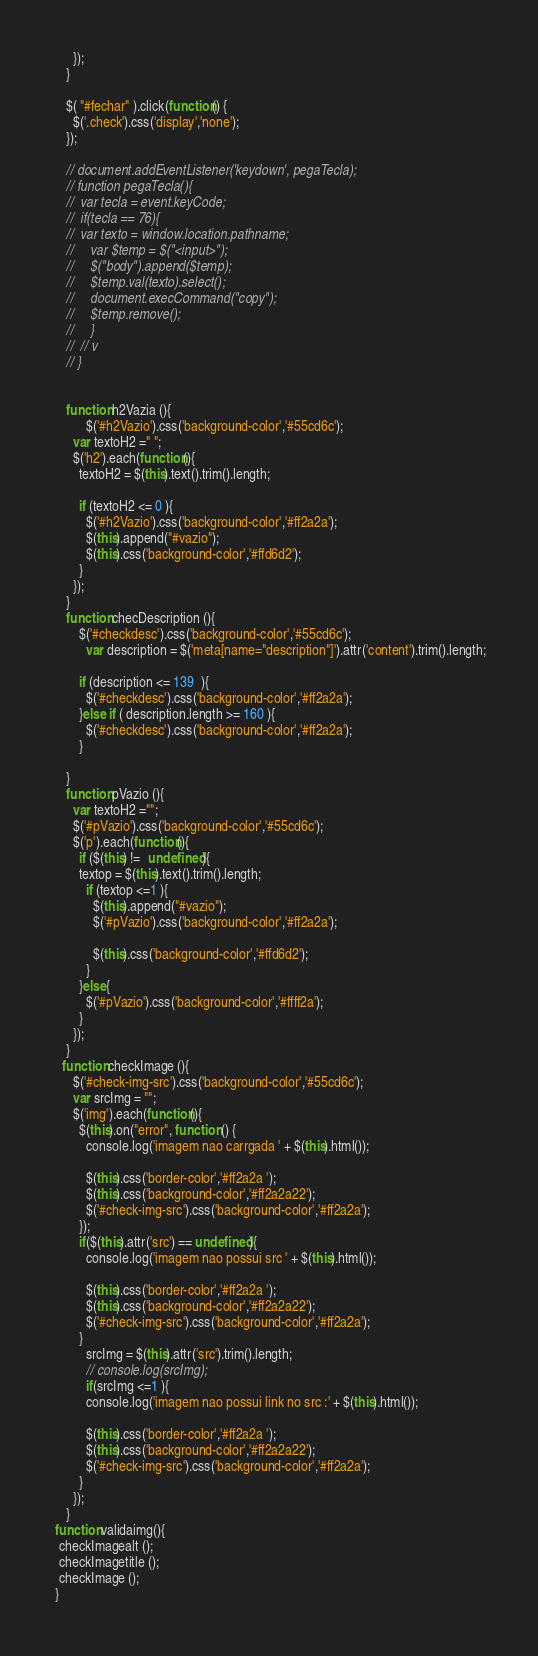Convert code to text. <code><loc_0><loc_0><loc_500><loc_500><_JavaScript_>      });
    }

    $( "#fechar" ).click(function() {
      $('.check').css('display','none');
    });

    // document.addEventListener('keydown', pegaTecla);
    // function pegaTecla(){
    //  var tecla = event.keyCode;
    //  if(tecla == 76){
    //  var texto = window.location.pathname;
    //     var $temp = $("<input>");
    //     $("body").append($temp);
    //     $temp.val(texto).select();
    //     document.execCommand("copy");
    //     $temp.remove();
    //     }
    //  // v
    // }


    function h2Vazia (){
          $('#h2Vazio').css('background-color','#55cd6c');
      var textoH2 =" ";
      $('h2').each(function(){
        textoH2 = $(this).text().trim().length;

        if (textoH2 <= 0 ){
          $('#h2Vazio').css('background-color','#ff2a2a');
          $(this).append("#vazio");
          $(this).css('background-color','#ffd6d2');
        }
      });
    }    
    function checDescription (){
        $('#checkdesc').css('background-color','#55cd6c');
          var description = $('meta[name="description"]').attr('content').trim().length;
          
        if (description <= 139  ){
          $('#checkdesc').css('background-color','#ff2a2a');
        }else if ( description.length >= 160 ){
          $('#checkdesc').css('background-color','#ff2a2a');
        }

    }
    function pVazio (){
      var textoH2 ="";
      $('#pVazio').css('background-color','#55cd6c');
      $('p').each(function(){
        if ($(this) !=  undefined){
        textop = $(this).text().trim().length;
          if (textop <=1 ){
            $(this).append("#vazio");
            $('#pVazio').css('background-color','#ff2a2a');
         
            $(this).css('background-color','#ffd6d2');
          }
        }else{
          $('#pVazio').css('background-color','#ffff2a');
        }
      });
    }
   function checkImage (){
      $('#check-img-src').css('background-color','#55cd6c');
      var srcImg = "";
      $('img').each(function(){
        $(this).on("error", function () {
          console.log('imagem nao carrgada ' + $(this).html());
          
          $(this).css('border-color','#ff2a2a ');
          $(this).css('background-color','#ff2a2a22');
          $('#check-img-src').css('background-color','#ff2a2a');
        });
        if($(this).attr('src') == undefined){
          console.log('imagem nao possui src ' + $(this).html());
          
          $(this).css('border-color','#ff2a2a ');
          $(this).css('background-color','#ff2a2a22');
          $('#check-img-src').css('background-color','#ff2a2a');
        }
          srcImg = $(this).attr('src').trim().length;
          // console.log(srcImg);
          if(srcImg <=1 ){
          console.log('imagem nao possui link no src :' + $(this).html());
          
          $(this).css('border-color','#ff2a2a ');
          $(this).css('background-color','#ff2a2a22');
          $('#check-img-src').css('background-color','#ff2a2a');
        }
      });
    }
 function validaimg(){
  checkImagealt ();
  checkImagetitle ();
  checkImage ();  
 }</code> 